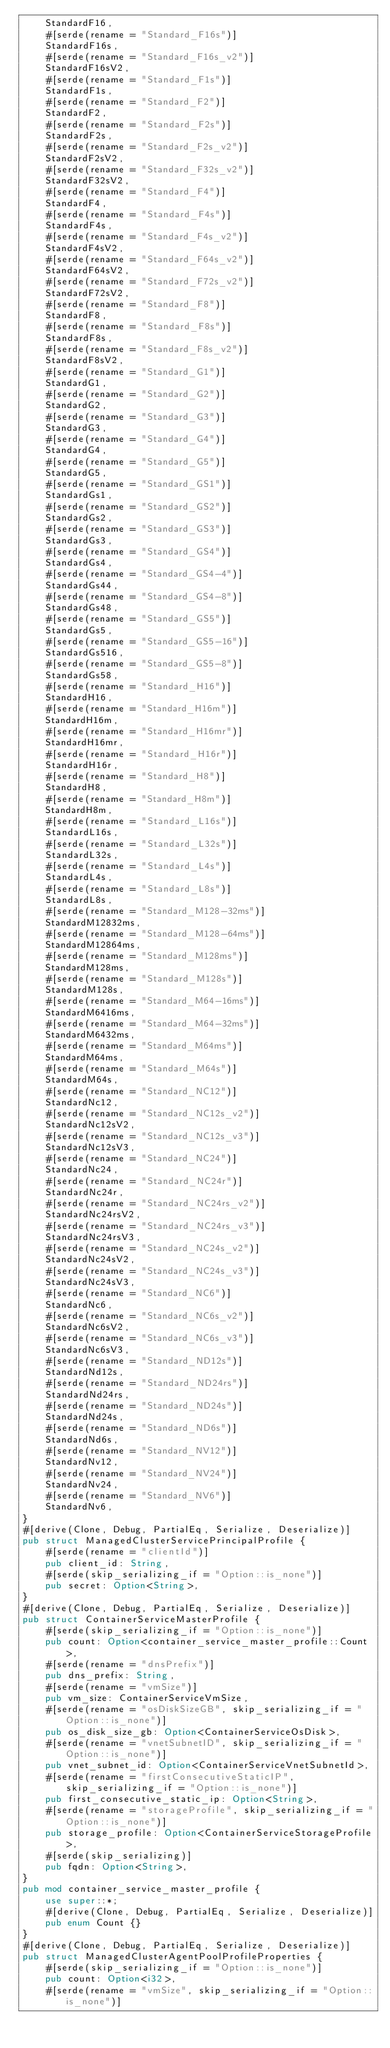Convert code to text. <code><loc_0><loc_0><loc_500><loc_500><_Rust_>    StandardF16,
    #[serde(rename = "Standard_F16s")]
    StandardF16s,
    #[serde(rename = "Standard_F16s_v2")]
    StandardF16sV2,
    #[serde(rename = "Standard_F1s")]
    StandardF1s,
    #[serde(rename = "Standard_F2")]
    StandardF2,
    #[serde(rename = "Standard_F2s")]
    StandardF2s,
    #[serde(rename = "Standard_F2s_v2")]
    StandardF2sV2,
    #[serde(rename = "Standard_F32s_v2")]
    StandardF32sV2,
    #[serde(rename = "Standard_F4")]
    StandardF4,
    #[serde(rename = "Standard_F4s")]
    StandardF4s,
    #[serde(rename = "Standard_F4s_v2")]
    StandardF4sV2,
    #[serde(rename = "Standard_F64s_v2")]
    StandardF64sV2,
    #[serde(rename = "Standard_F72s_v2")]
    StandardF72sV2,
    #[serde(rename = "Standard_F8")]
    StandardF8,
    #[serde(rename = "Standard_F8s")]
    StandardF8s,
    #[serde(rename = "Standard_F8s_v2")]
    StandardF8sV2,
    #[serde(rename = "Standard_G1")]
    StandardG1,
    #[serde(rename = "Standard_G2")]
    StandardG2,
    #[serde(rename = "Standard_G3")]
    StandardG3,
    #[serde(rename = "Standard_G4")]
    StandardG4,
    #[serde(rename = "Standard_G5")]
    StandardG5,
    #[serde(rename = "Standard_GS1")]
    StandardGs1,
    #[serde(rename = "Standard_GS2")]
    StandardGs2,
    #[serde(rename = "Standard_GS3")]
    StandardGs3,
    #[serde(rename = "Standard_GS4")]
    StandardGs4,
    #[serde(rename = "Standard_GS4-4")]
    StandardGs44,
    #[serde(rename = "Standard_GS4-8")]
    StandardGs48,
    #[serde(rename = "Standard_GS5")]
    StandardGs5,
    #[serde(rename = "Standard_GS5-16")]
    StandardGs516,
    #[serde(rename = "Standard_GS5-8")]
    StandardGs58,
    #[serde(rename = "Standard_H16")]
    StandardH16,
    #[serde(rename = "Standard_H16m")]
    StandardH16m,
    #[serde(rename = "Standard_H16mr")]
    StandardH16mr,
    #[serde(rename = "Standard_H16r")]
    StandardH16r,
    #[serde(rename = "Standard_H8")]
    StandardH8,
    #[serde(rename = "Standard_H8m")]
    StandardH8m,
    #[serde(rename = "Standard_L16s")]
    StandardL16s,
    #[serde(rename = "Standard_L32s")]
    StandardL32s,
    #[serde(rename = "Standard_L4s")]
    StandardL4s,
    #[serde(rename = "Standard_L8s")]
    StandardL8s,
    #[serde(rename = "Standard_M128-32ms")]
    StandardM12832ms,
    #[serde(rename = "Standard_M128-64ms")]
    StandardM12864ms,
    #[serde(rename = "Standard_M128ms")]
    StandardM128ms,
    #[serde(rename = "Standard_M128s")]
    StandardM128s,
    #[serde(rename = "Standard_M64-16ms")]
    StandardM6416ms,
    #[serde(rename = "Standard_M64-32ms")]
    StandardM6432ms,
    #[serde(rename = "Standard_M64ms")]
    StandardM64ms,
    #[serde(rename = "Standard_M64s")]
    StandardM64s,
    #[serde(rename = "Standard_NC12")]
    StandardNc12,
    #[serde(rename = "Standard_NC12s_v2")]
    StandardNc12sV2,
    #[serde(rename = "Standard_NC12s_v3")]
    StandardNc12sV3,
    #[serde(rename = "Standard_NC24")]
    StandardNc24,
    #[serde(rename = "Standard_NC24r")]
    StandardNc24r,
    #[serde(rename = "Standard_NC24rs_v2")]
    StandardNc24rsV2,
    #[serde(rename = "Standard_NC24rs_v3")]
    StandardNc24rsV3,
    #[serde(rename = "Standard_NC24s_v2")]
    StandardNc24sV2,
    #[serde(rename = "Standard_NC24s_v3")]
    StandardNc24sV3,
    #[serde(rename = "Standard_NC6")]
    StandardNc6,
    #[serde(rename = "Standard_NC6s_v2")]
    StandardNc6sV2,
    #[serde(rename = "Standard_NC6s_v3")]
    StandardNc6sV3,
    #[serde(rename = "Standard_ND12s")]
    StandardNd12s,
    #[serde(rename = "Standard_ND24rs")]
    StandardNd24rs,
    #[serde(rename = "Standard_ND24s")]
    StandardNd24s,
    #[serde(rename = "Standard_ND6s")]
    StandardNd6s,
    #[serde(rename = "Standard_NV12")]
    StandardNv12,
    #[serde(rename = "Standard_NV24")]
    StandardNv24,
    #[serde(rename = "Standard_NV6")]
    StandardNv6,
}
#[derive(Clone, Debug, PartialEq, Serialize, Deserialize)]
pub struct ManagedClusterServicePrincipalProfile {
    #[serde(rename = "clientId")]
    pub client_id: String,
    #[serde(skip_serializing_if = "Option::is_none")]
    pub secret: Option<String>,
}
#[derive(Clone, Debug, PartialEq, Serialize, Deserialize)]
pub struct ContainerServiceMasterProfile {
    #[serde(skip_serializing_if = "Option::is_none")]
    pub count: Option<container_service_master_profile::Count>,
    #[serde(rename = "dnsPrefix")]
    pub dns_prefix: String,
    #[serde(rename = "vmSize")]
    pub vm_size: ContainerServiceVmSize,
    #[serde(rename = "osDiskSizeGB", skip_serializing_if = "Option::is_none")]
    pub os_disk_size_gb: Option<ContainerServiceOsDisk>,
    #[serde(rename = "vnetSubnetID", skip_serializing_if = "Option::is_none")]
    pub vnet_subnet_id: Option<ContainerServiceVnetSubnetId>,
    #[serde(rename = "firstConsecutiveStaticIP", skip_serializing_if = "Option::is_none")]
    pub first_consecutive_static_ip: Option<String>,
    #[serde(rename = "storageProfile", skip_serializing_if = "Option::is_none")]
    pub storage_profile: Option<ContainerServiceStorageProfile>,
    #[serde(skip_serializing)]
    pub fqdn: Option<String>,
}
pub mod container_service_master_profile {
    use super::*;
    #[derive(Clone, Debug, PartialEq, Serialize, Deserialize)]
    pub enum Count {}
}
#[derive(Clone, Debug, PartialEq, Serialize, Deserialize)]
pub struct ManagedClusterAgentPoolProfileProperties {
    #[serde(skip_serializing_if = "Option::is_none")]
    pub count: Option<i32>,
    #[serde(rename = "vmSize", skip_serializing_if = "Option::is_none")]</code> 